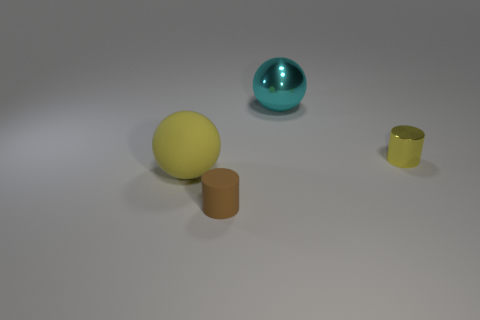Add 3 small cyan matte cubes. How many objects exist? 7 Add 3 yellow shiny cylinders. How many yellow shiny cylinders are left? 4 Add 2 cyan things. How many cyan things exist? 3 Subtract 0 blue balls. How many objects are left? 4 Subtract all big yellow shiny cylinders. Subtract all big cyan objects. How many objects are left? 3 